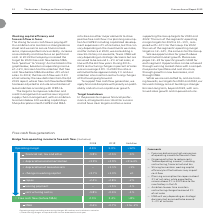According to Lm Ericsson Telephone's financial document, What is the operating margin in 2018? According to the financial document, 4.4%. The relevant text states: "4.4%..." Also, What is the operating margin in 2019? According to the financial document, 5.0%. The relevant text states: "5.0%..." Also, What is the M&A cash flow percentage in 2019? According to the financial document, -0.7%. The relevant text states: "-0.7%..." Also, can you calculate: What is the change in capex between 2018 and 2019? Based on the calculation: -2.4- (-2.8) , the result is 0.4 (percentage). This is based on the information: "turing charges in percent of sales was on average 2.8%. In 2020 the ratio is estimated to be approximately 1% and our ambition is to maintain restructuri -2.4%..." The key data points involved are: 2.4, 2.8. Additionally, Which year has a higher free cash flow (before M&A)? According to the financial document, 2019. The relevant text states: "Ericsson Annual Report 2019 12 The business – Strategy and financial targets..." Also, can you calculate: What is the change in operating margin between 2018 and 2019? Based on the calculation: 5.0-4.4, the result is 0.6 (percentage). This is based on the information: "5.0% 4.4%..." The key data points involved are: 4.4, 5.0. 